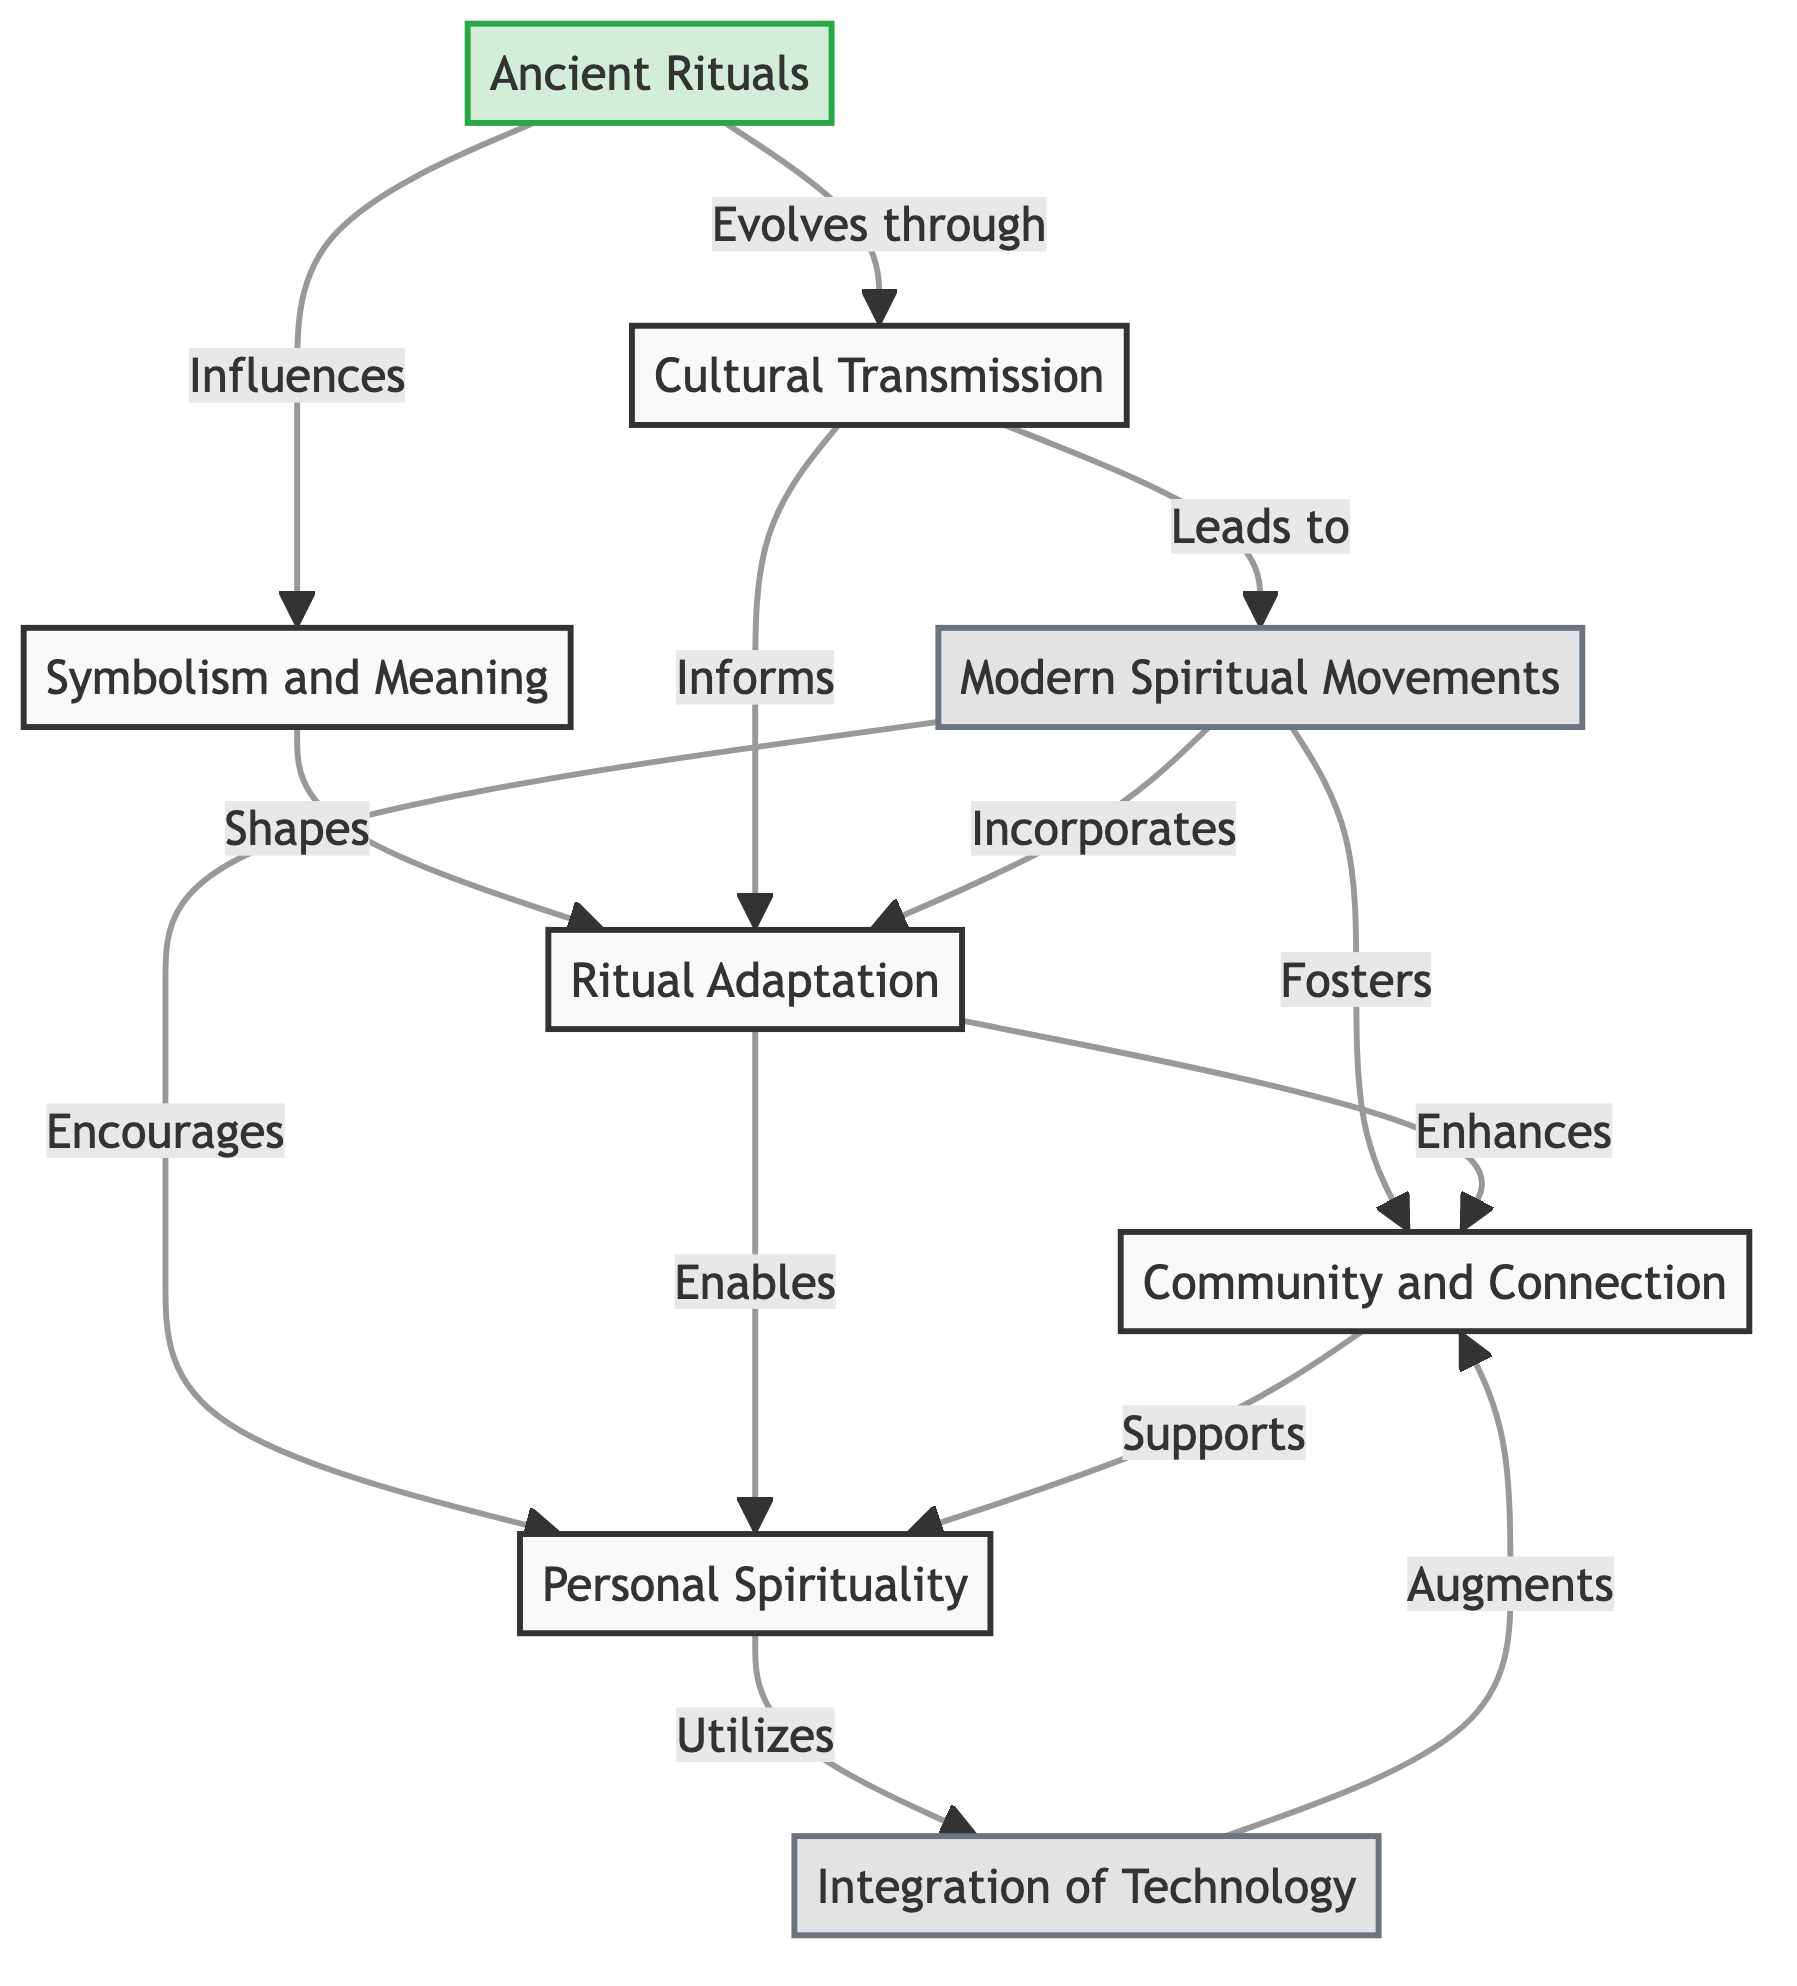What is the starting point of the flow chart? The first element in the flow chart is "Ancient Rituals," which serves as the foundational concept from which other elements are derived or influenced.
Answer: Ancient Rituals How many nodes are in the flow chart? By counting all the unique elements listed in the diagram, there are a total of eight nodes representing different concepts related to ancient rituals and modern spiritual practices.
Answer: 8 Which node directly evolves from "Symbolism and Meaning"? The node that derives its significance from "Symbolism and Meaning" is "Ritual Adaptation," indicating that understanding the symbolism plays a critical role in how rituals are modified.
Answer: Ritual Adaptation What does "Cultural Transmission" lead to? According to the flow chart, "Cultural Transmission" leads to "Modern Spiritual Movements," indicating that the passing down of ancient practices has a direct impact on contemporary spiritual expressions.
Answer: Modern Spiritual Movements Which nodes are categorized as modern? The nodes designated as modern in the diagram are "Modern Spiritual Movements," "Integration of Technology," and "Personal Spirituality," highlighting their contemporary context in relation to ancient beliefs.
Answer: Modern Spiritual Movements, Integration of Technology, Personal Spirituality How does "Ritual Adaptation" enhance community practices? The flow chart illustrates that "Ritual Adaptation" enhances "Community and Connection," which suggests that modifying rituals helps create a stronger sense of belonging among individuals who share similar spiritual experiences.
Answer: Community and Connection What is the relationship between "Community and Connection" and "Personal Spirituality"? "Community and Connection" supports "Personal Spirituality," indicating that a sense of community can provide a foundation for individual spiritual practices and the exploration of personal beliefs.
Answer: Supports What role does "Integration of Technology" play in "Community and Connection"? The diagram shows that "Integration of Technology" augments "Community and Connection," meaning that modern tools and technologies enhance the communal aspects of spiritual practices.
Answer: Augments Which node suggests the influence of individualized practices on technology? The node "Personal Spirituality" suggests that individualized practices actively utilize "Integration of Technology," reflecting how personal spiritual journeys may incorporate modern innovations for enhancement.
Answer: Utilizes 